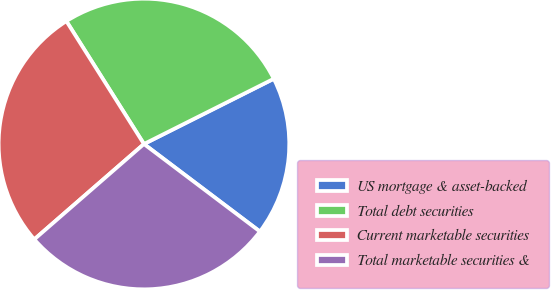<chart> <loc_0><loc_0><loc_500><loc_500><pie_chart><fcel>US mortgage & asset-backed<fcel>Total debt securities<fcel>Current marketable securities<fcel>Total marketable securities &<nl><fcel>17.7%<fcel>26.55%<fcel>27.43%<fcel>28.32%<nl></chart> 